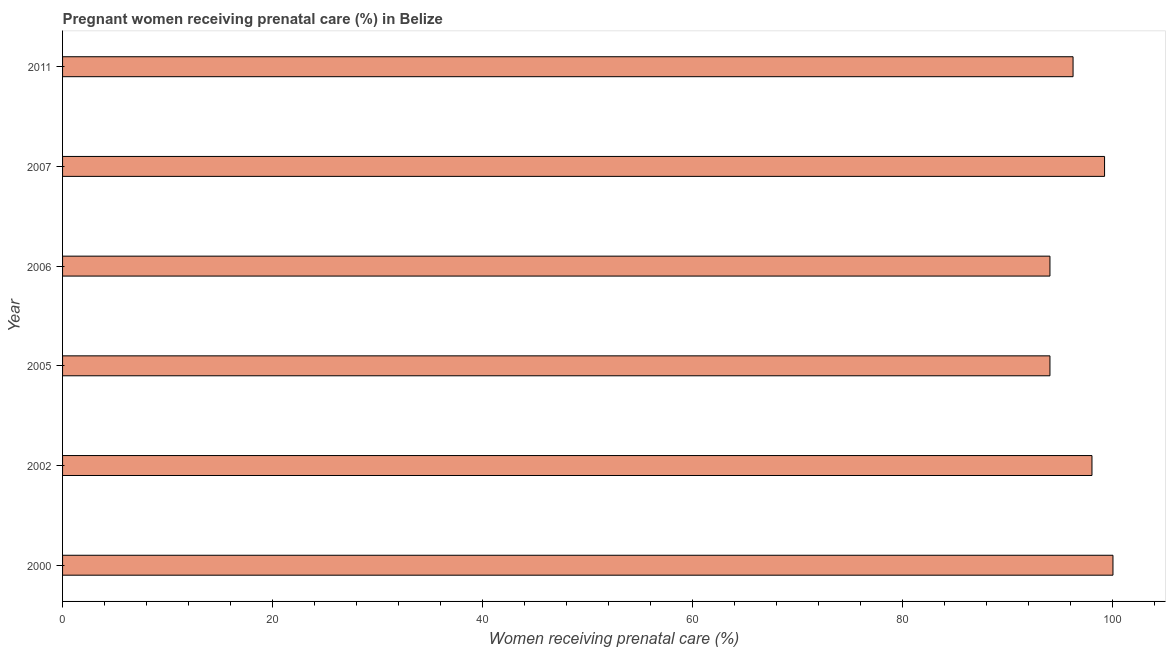What is the title of the graph?
Ensure brevity in your answer.  Pregnant women receiving prenatal care (%) in Belize. What is the label or title of the X-axis?
Your response must be concise. Women receiving prenatal care (%). What is the percentage of pregnant women receiving prenatal care in 2007?
Keep it short and to the point. 99.2. Across all years, what is the minimum percentage of pregnant women receiving prenatal care?
Make the answer very short. 94. In which year was the percentage of pregnant women receiving prenatal care minimum?
Keep it short and to the point. 2005. What is the sum of the percentage of pregnant women receiving prenatal care?
Ensure brevity in your answer.  581.4. What is the average percentage of pregnant women receiving prenatal care per year?
Ensure brevity in your answer.  96.9. What is the median percentage of pregnant women receiving prenatal care?
Keep it short and to the point. 97.1. What is the ratio of the percentage of pregnant women receiving prenatal care in 2006 to that in 2007?
Provide a short and direct response. 0.95. Is the percentage of pregnant women receiving prenatal care in 2000 less than that in 2006?
Your answer should be very brief. No. Is the sum of the percentage of pregnant women receiving prenatal care in 2000 and 2005 greater than the maximum percentage of pregnant women receiving prenatal care across all years?
Your answer should be compact. Yes. What is the difference between the highest and the lowest percentage of pregnant women receiving prenatal care?
Give a very brief answer. 6. In how many years, is the percentage of pregnant women receiving prenatal care greater than the average percentage of pregnant women receiving prenatal care taken over all years?
Your answer should be very brief. 3. How many bars are there?
Your answer should be very brief. 6. How many years are there in the graph?
Offer a terse response. 6. What is the difference between two consecutive major ticks on the X-axis?
Offer a very short reply. 20. Are the values on the major ticks of X-axis written in scientific E-notation?
Ensure brevity in your answer.  No. What is the Women receiving prenatal care (%) of 2002?
Your response must be concise. 98. What is the Women receiving prenatal care (%) in 2005?
Your answer should be compact. 94. What is the Women receiving prenatal care (%) in 2006?
Your response must be concise. 94. What is the Women receiving prenatal care (%) in 2007?
Provide a short and direct response. 99.2. What is the Women receiving prenatal care (%) of 2011?
Ensure brevity in your answer.  96.2. What is the difference between the Women receiving prenatal care (%) in 2000 and 2005?
Offer a very short reply. 6. What is the difference between the Women receiving prenatal care (%) in 2000 and 2006?
Offer a very short reply. 6. What is the difference between the Women receiving prenatal care (%) in 2000 and 2011?
Ensure brevity in your answer.  3.8. What is the difference between the Women receiving prenatal care (%) in 2005 and 2006?
Your response must be concise. 0. What is the difference between the Women receiving prenatal care (%) in 2005 and 2007?
Your answer should be very brief. -5.2. What is the difference between the Women receiving prenatal care (%) in 2005 and 2011?
Provide a succinct answer. -2.2. What is the difference between the Women receiving prenatal care (%) in 2006 and 2007?
Offer a terse response. -5.2. What is the difference between the Women receiving prenatal care (%) in 2007 and 2011?
Provide a short and direct response. 3. What is the ratio of the Women receiving prenatal care (%) in 2000 to that in 2002?
Your answer should be very brief. 1.02. What is the ratio of the Women receiving prenatal care (%) in 2000 to that in 2005?
Give a very brief answer. 1.06. What is the ratio of the Women receiving prenatal care (%) in 2000 to that in 2006?
Your response must be concise. 1.06. What is the ratio of the Women receiving prenatal care (%) in 2000 to that in 2007?
Give a very brief answer. 1.01. What is the ratio of the Women receiving prenatal care (%) in 2000 to that in 2011?
Ensure brevity in your answer.  1.04. What is the ratio of the Women receiving prenatal care (%) in 2002 to that in 2005?
Your response must be concise. 1.04. What is the ratio of the Women receiving prenatal care (%) in 2002 to that in 2006?
Your answer should be very brief. 1.04. What is the ratio of the Women receiving prenatal care (%) in 2002 to that in 2011?
Your answer should be compact. 1.02. What is the ratio of the Women receiving prenatal care (%) in 2005 to that in 2007?
Your answer should be very brief. 0.95. What is the ratio of the Women receiving prenatal care (%) in 2005 to that in 2011?
Offer a terse response. 0.98. What is the ratio of the Women receiving prenatal care (%) in 2006 to that in 2007?
Give a very brief answer. 0.95. What is the ratio of the Women receiving prenatal care (%) in 2006 to that in 2011?
Ensure brevity in your answer.  0.98. What is the ratio of the Women receiving prenatal care (%) in 2007 to that in 2011?
Your answer should be very brief. 1.03. 